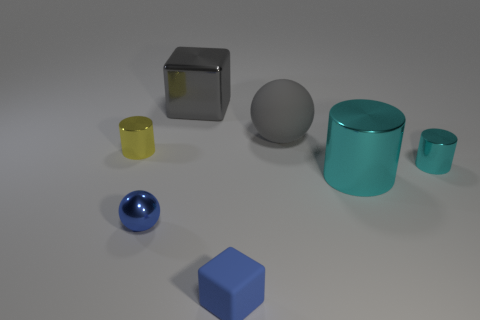How many things are either tiny objects behind the blue metal sphere or big shiny objects?
Your answer should be compact. 4. Is the number of gray matte things less than the number of red metal cylinders?
Make the answer very short. No. The blue thing that is the same material as the big cyan cylinder is what shape?
Offer a very short reply. Sphere. Are there any small objects behind the small block?
Offer a very short reply. Yes. Are there fewer large gray shiny blocks to the right of the small blue cube than yellow cylinders?
Make the answer very short. Yes. What is the material of the tiny sphere?
Ensure brevity in your answer.  Metal. The small sphere has what color?
Offer a very short reply. Blue. The object that is both on the right side of the big gray shiny thing and on the left side of the gray matte sphere is what color?
Your answer should be compact. Blue. Is there anything else that has the same material as the large cyan thing?
Provide a succinct answer. Yes. Is the material of the big gray sphere the same as the blue thing left of the large shiny block?
Provide a succinct answer. No. 